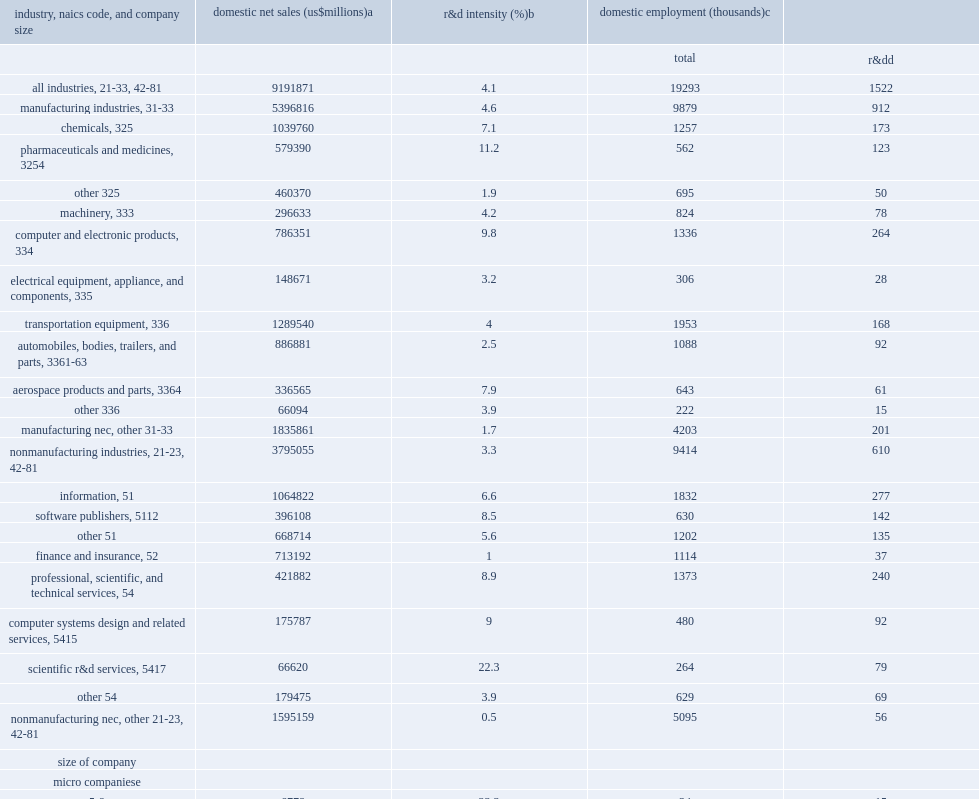Can you give me this table as a dict? {'header': ['industry, naics code, and company size', 'domestic net sales (us$millions)a', 'r&d intensity (%)b', 'domestic employment (thousands)c', ''], 'rows': [['', '', '', 'total', 'r&dd'], ['all industries, 21-33, 42-81', '9191871', '4.1', '19293', '1522'], ['manufacturing industries, 31-33', '5396816', '4.6', '9879', '912'], ['chemicals, 325', '1039760', '7.1', '1257', '173'], ['pharmaceuticals and medicines, 3254', '579390', '11.2', '562', '123'], ['other 325', '460370', '1.9', '695', '50'], ['machinery, 333', '296633', '4.2', '824', '78'], ['computer and electronic products, 334', '786351', '9.8', '1336', '264'], ['electrical equipment, appliance, and components, 335', '148671', '3.2', '306', '28'], ['transportation equipment, 336', '1289540', '4', '1953', '168'], ['automobiles, bodies, trailers, and parts, 3361-63', '886881', '2.5', '1088', '92'], ['aerospace products and parts, 3364', '336565', '7.9', '643', '61'], ['other 336', '66094', '3.9', '222', '15'], ['manufacturing nec, other 31-33', '1835861', '1.7', '4203', '201'], ['nonmanufacturing industries, 21-23, 42-81', '3795055', '3.3', '9414', '610'], ['information, 51', '1064822', '6.6', '1832', '277'], ['software publishers, 5112', '396108', '8.5', '630', '142'], ['other 51', '668714', '5.6', '1202', '135'], ['finance and insurance, 52', '713192', '1', '1114', '37'], ['professional, scientific, and technical services, 54', '421882', '8.9', '1373', '240'], ['computer systems design and related services, 5415', '175787', '9', '480', '92'], ['scientific r&d services, 5417', '66620', '22.3', '264', '79'], ['other 54', '179475', '3.9', '629', '69'], ['nonmanufacturing nec, other 21-23, 42-81', '1595159', '0.5', '5095', '56'], ['size of company', '', '', '', ''], ['micro companiese', '', '', '', ''], ['5-9', '6778', '23.3', '34', '15'], ['small companies', '', '', '', ''], ['10-19', '25795', '19.2', '111', '37'], ['20-49', '100067', '9.7', '323', '75'], ['medium companies', '', '', '', ''], ['50-99', '113696', '8.2', '413', '69'], ['100-249', '271388', '5.5', '764', '101'], ['large companies', '', '', '', ''], ['250-499', '276513', '4.7', '700', '75'], ['500-999', '326260', '4.4', '739', '74'], ['1,000-4,999', '1238059', '5.2', '2583', '278'], ['5,000-9,999', '994329', '4.1', '1859', '159'], ['10,000-24,999', '1677581', '3.9', '2898', '243'], ['25,000 or more', '4161406', '3.3', '8869', '395']]} How many trillion dollars did u.s. companies that performed or funded r&d report domestic net sales in 2016? 9191871.0. For all industries, what was the percentage points of the r&d intensity? 4.1. For manufacturers, what was percentgae points of the r&d intensity? 4.6. For non-manufacturers, what was percentgae points of the r&d intensity? 3.3. 